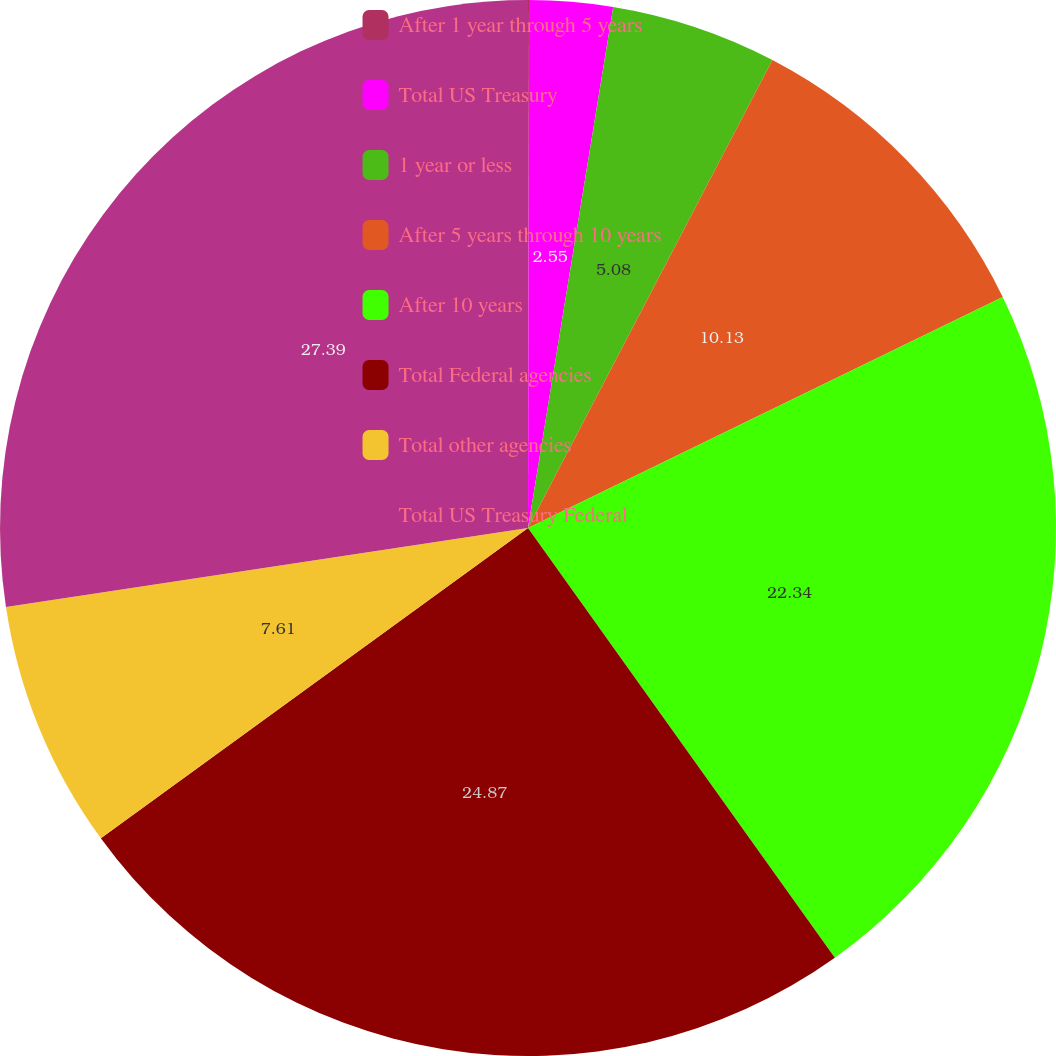Convert chart to OTSL. <chart><loc_0><loc_0><loc_500><loc_500><pie_chart><fcel>After 1 year through 5 years<fcel>Total US Treasury<fcel>1 year or less<fcel>After 5 years through 10 years<fcel>After 10 years<fcel>Total Federal agencies<fcel>Total other agencies<fcel>Total US Treasury Federal<nl><fcel>0.03%<fcel>2.55%<fcel>5.08%<fcel>10.13%<fcel>22.34%<fcel>24.87%<fcel>7.61%<fcel>27.39%<nl></chart> 